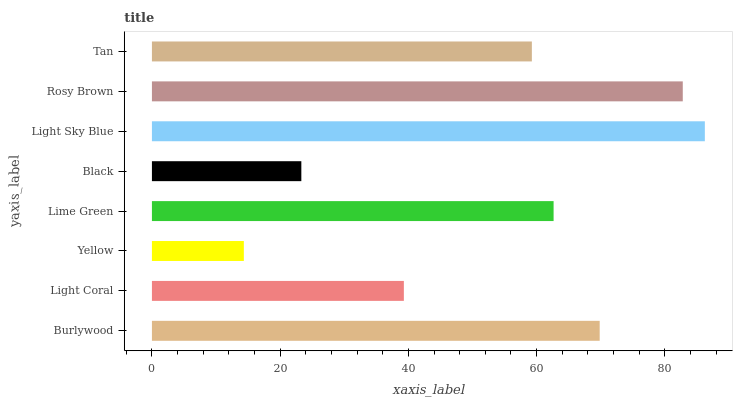Is Yellow the minimum?
Answer yes or no. Yes. Is Light Sky Blue the maximum?
Answer yes or no. Yes. Is Light Coral the minimum?
Answer yes or no. No. Is Light Coral the maximum?
Answer yes or no. No. Is Burlywood greater than Light Coral?
Answer yes or no. Yes. Is Light Coral less than Burlywood?
Answer yes or no. Yes. Is Light Coral greater than Burlywood?
Answer yes or no. No. Is Burlywood less than Light Coral?
Answer yes or no. No. Is Lime Green the high median?
Answer yes or no. Yes. Is Tan the low median?
Answer yes or no. Yes. Is Yellow the high median?
Answer yes or no. No. Is Yellow the low median?
Answer yes or no. No. 